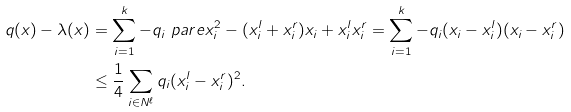<formula> <loc_0><loc_0><loc_500><loc_500>q ( x ) - \lambda ( x ) & = \sum _ { i = 1 } ^ { k } - q _ { i } \ p a r e { x _ { i } ^ { 2 } - ( x ^ { l } _ { i } + x ^ { r } _ { i } ) x _ { i } + x ^ { l } _ { i } x ^ { r } _ { i } } = \sum _ { i = 1 } ^ { k } - q _ { i } ( x _ { i } - x ^ { l } _ { i } ) ( x _ { i } - x ^ { r } _ { i } ) \\ & \leq \frac { 1 } { 4 } \sum _ { i \in N ^ { \ell } } q _ { i } ( x ^ { l } _ { i } - x ^ { r } _ { i } ) ^ { 2 } .</formula> 